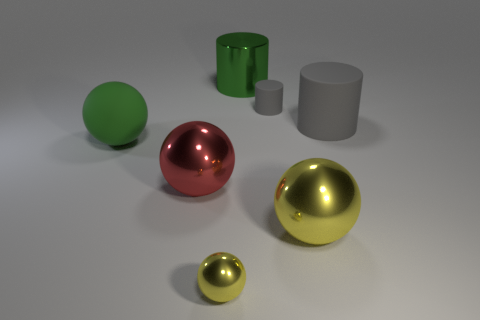There is a red sphere that is made of the same material as the large green cylinder; what is its size?
Offer a very short reply. Large. Is the number of tiny balls greater than the number of big balls?
Your answer should be very brief. No. What is the material of the gray cylinder that is the same size as the red ball?
Give a very brief answer. Rubber. There is a ball that is behind the red metallic ball; is its size the same as the large red metal ball?
Your response must be concise. Yes. What number of blocks are either green objects or purple things?
Your response must be concise. 0. There is a big green thing in front of the large matte cylinder; what is it made of?
Keep it short and to the point. Rubber. Are there fewer large brown rubber cylinders than gray matte cylinders?
Ensure brevity in your answer.  Yes. There is a object that is in front of the green rubber sphere and behind the big yellow metal thing; what size is it?
Make the answer very short. Large. What is the size of the matte thing on the left side of the tiny thing to the left of the big metal thing behind the rubber ball?
Your answer should be very brief. Large. What number of other things are there of the same color as the metal cylinder?
Give a very brief answer. 1. 